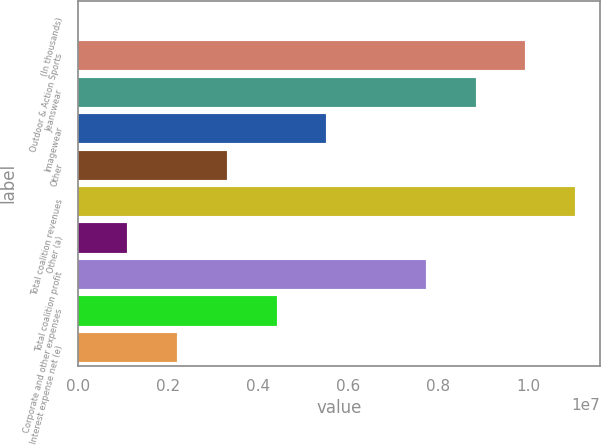Convert chart to OTSL. <chart><loc_0><loc_0><loc_500><loc_500><bar_chart><fcel>(In thousands)<fcel>Outdoor & Action Sports<fcel>Jeanswear<fcel>Imagewear<fcel>Other<fcel>Total coalition revenues<fcel>Other (a)<fcel>Total coalition profit<fcel>Corporate and other expenses<fcel>Interest expense net (e)<nl><fcel>2016<fcel>9.92373e+06<fcel>8.82132e+06<fcel>5.51408e+06<fcel>3.30926e+06<fcel>1.10261e+07<fcel>1.10443e+06<fcel>7.71891e+06<fcel>4.41167e+06<fcel>2.20684e+06<nl></chart> 